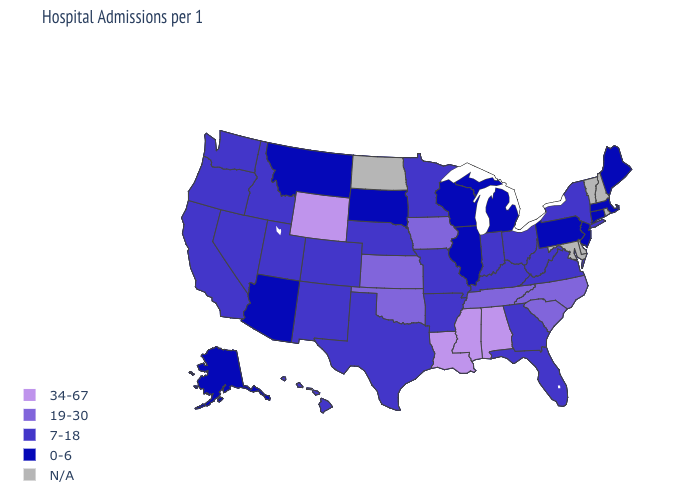What is the value of Alabama?
Quick response, please. 34-67. What is the value of Illinois?
Keep it brief. 0-6. Which states hav the highest value in the South?
Give a very brief answer. Alabama, Louisiana, Mississippi. How many symbols are there in the legend?
Give a very brief answer. 5. Name the states that have a value in the range 34-67?
Keep it brief. Alabama, Louisiana, Mississippi, Wyoming. Among the states that border Nevada , which have the highest value?
Short answer required. California, Idaho, Oregon, Utah. What is the value of Massachusetts?
Answer briefly. 0-6. What is the lowest value in states that border Oregon?
Be succinct. 7-18. What is the lowest value in the MidWest?
Give a very brief answer. 0-6. Among the states that border New Mexico , does Utah have the highest value?
Quick response, please. No. Name the states that have a value in the range 19-30?
Keep it brief. Iowa, Kansas, North Carolina, Oklahoma, South Carolina, Tennessee. What is the lowest value in the Northeast?
Concise answer only. 0-6. What is the value of Tennessee?
Answer briefly. 19-30. Among the states that border Nebraska , does Missouri have the lowest value?
Answer briefly. No. Name the states that have a value in the range 7-18?
Answer briefly. Arkansas, California, Colorado, Florida, Georgia, Hawaii, Idaho, Indiana, Kentucky, Minnesota, Missouri, Nebraska, Nevada, New Mexico, New York, Ohio, Oregon, Texas, Utah, Virginia, Washington, West Virginia. 